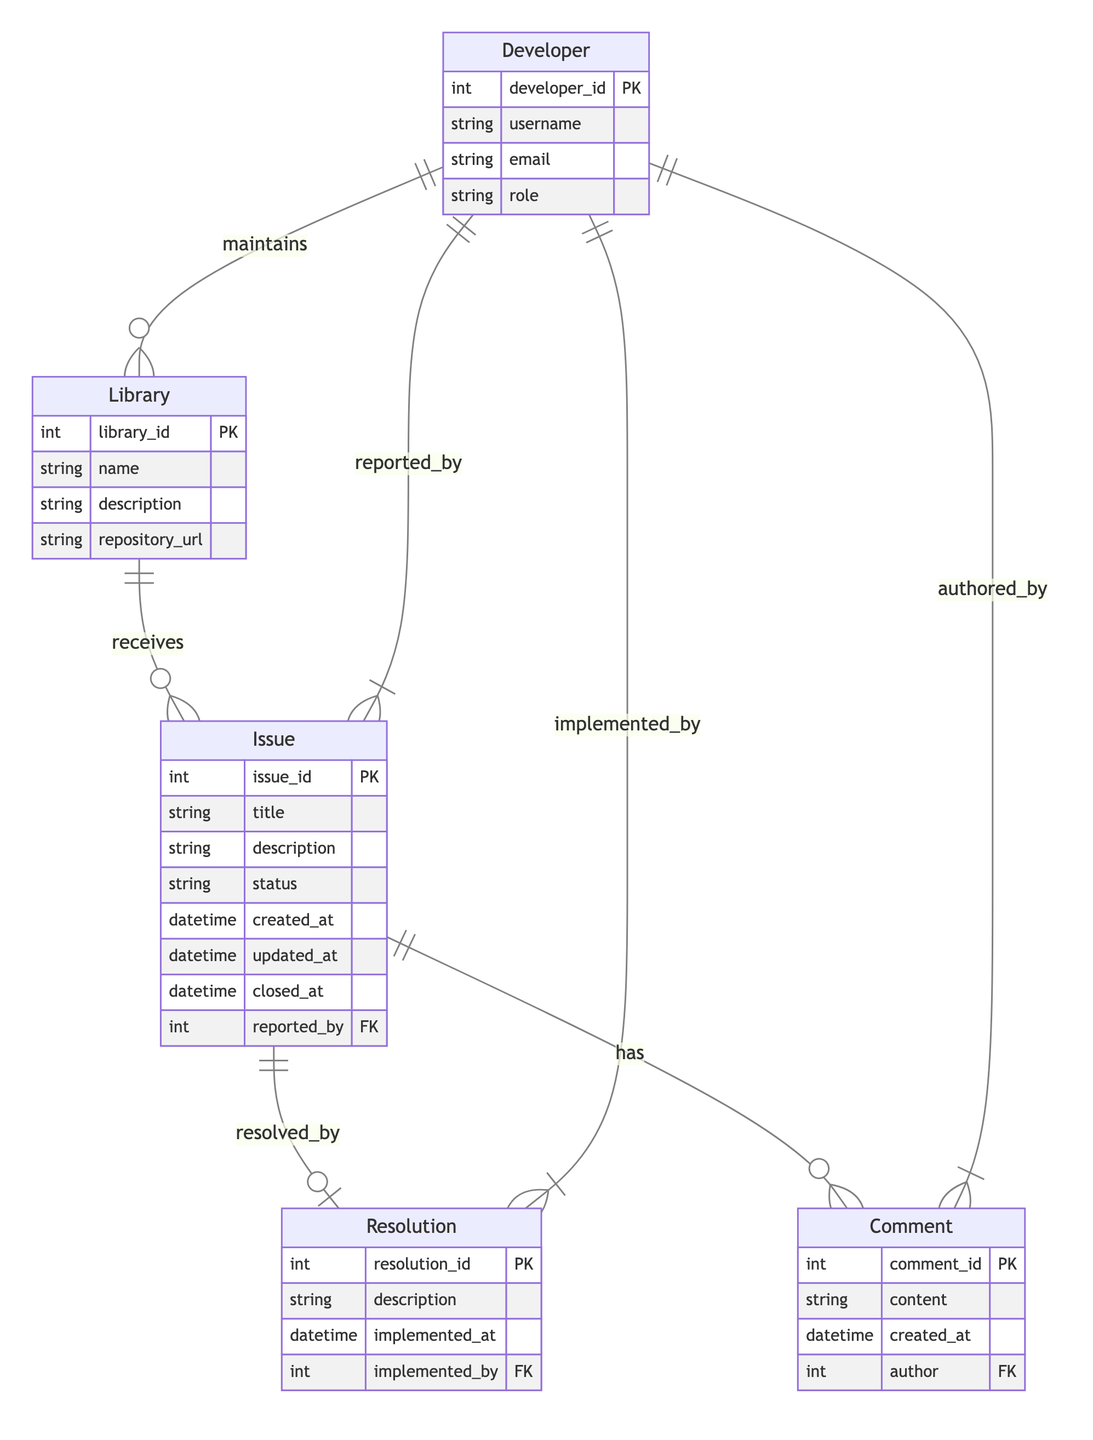What is the primary role of the Developer entity in the diagram? The Developer entity primarily maintains the Library entity, as indicated by the direct relationship between them labeled "maintains." This points out that developers are responsible for upkeep and management of libraries in the context of this workflow.
Answer: maintains How many attributes does the Issue entity have? The Issue entity has eight attributes: issue_id, title, description, status, created_at, updated_at, closed_at, and reported_by. This can be counted directly from the diagram’s specification under the Issue entity, confirming the total.
Answer: eight Which entity is responsible for implementing a Resolution? The Resolution entity is implemented by the Developer entity, as shown by the relationship labeled "implemented_by," which connects Resolution to Developer. This indicates that developers are the ones who carry out the actual fixes or changes as per the resolutions.
Answer: Developer What is the relationship type between Issue and Comment? The relationship type between Issue and Comment is "has," meaning that each issue can have multiple comments associated with it, indicating a one-to-many relationship from Issue to Comment in the diagram.
Answer: has What does the 'reported_by' relationship indicate about the Issue entity? The 'reported_by' relationship indicates that each Issue is associated with a specific Developer who reported it, which means that there is a direct link specifying which developer brought the issue to attention in the workflow.
Answer: Developer 